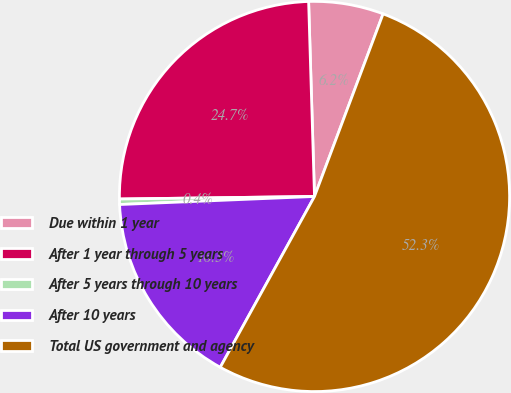Convert chart to OTSL. <chart><loc_0><loc_0><loc_500><loc_500><pie_chart><fcel>Due within 1 year<fcel>After 1 year through 5 years<fcel>After 5 years through 10 years<fcel>After 10 years<fcel>Total US government and agency<nl><fcel>6.2%<fcel>24.73%<fcel>0.45%<fcel>16.32%<fcel>52.31%<nl></chart> 